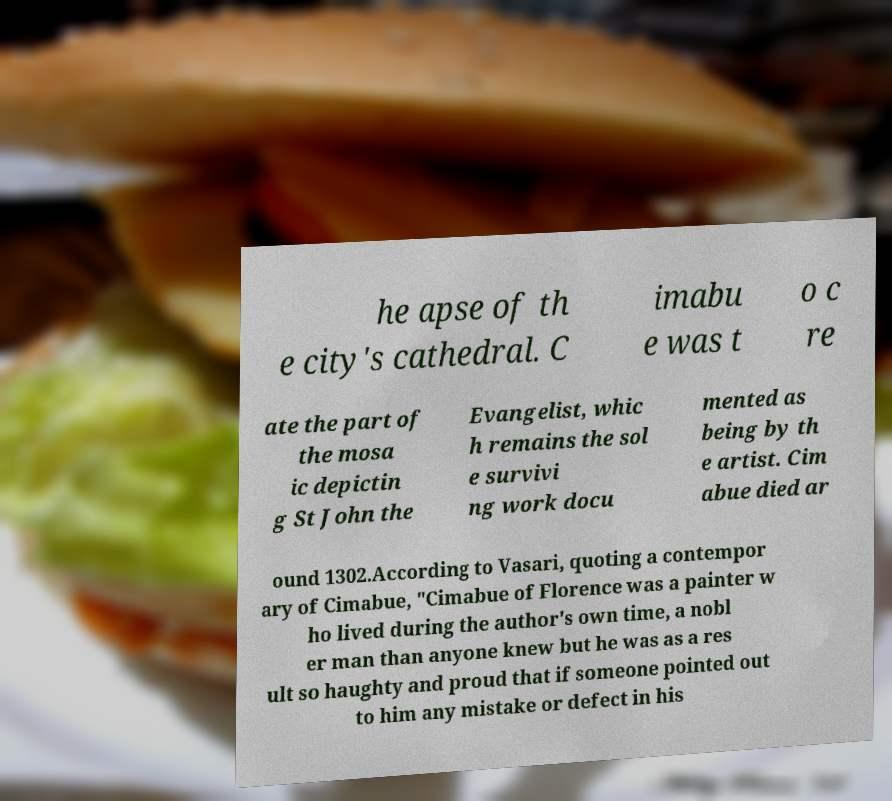There's text embedded in this image that I need extracted. Can you transcribe it verbatim? he apse of th e city's cathedral. C imabu e was t o c re ate the part of the mosa ic depictin g St John the Evangelist, whic h remains the sol e survivi ng work docu mented as being by th e artist. Cim abue died ar ound 1302.According to Vasari, quoting a contempor ary of Cimabue, "Cimabue of Florence was a painter w ho lived during the author's own time, a nobl er man than anyone knew but he was as a res ult so haughty and proud that if someone pointed out to him any mistake or defect in his 